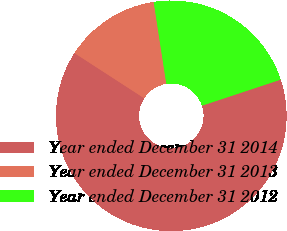Convert chart to OTSL. <chart><loc_0><loc_0><loc_500><loc_500><pie_chart><fcel>Year ended December 31 2014<fcel>Year ended December 31 2013<fcel>Year ended December 31 2012<nl><fcel>64.25%<fcel>13.41%<fcel>22.35%<nl></chart> 